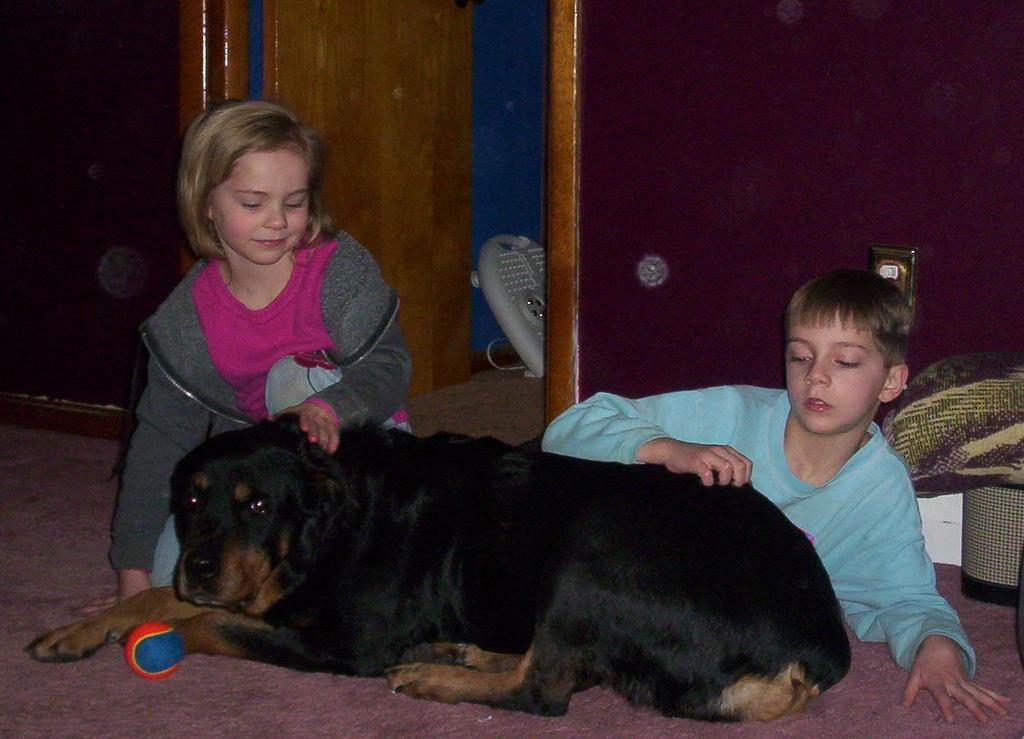What type of animal is in the image? There is a black dog in the image. What object is visible in the image that the dog might play with? There is a ball in the image. How many people are present in the image? There are two people sitting in the image. What type of structure can be seen in the background of the image? There is a wall in the image. Is there any entrance or exit visible in the image? Yes, there is a door in the image. What type of prose is being recited by the dog in the image? There is no prose being recited in the image, as it features a black dog, a ball, two people, a wall, and a door. Is there a maid present in the image? There is no mention of a maid in the image, as it only includes a black dog, a ball, two people, a wall, and a door. 